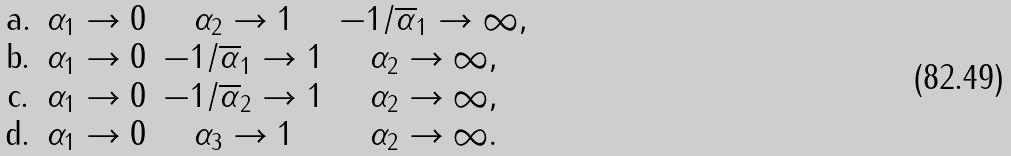Convert formula to latex. <formula><loc_0><loc_0><loc_500><loc_500>\begin{matrix} \text {a.} & \alpha _ { 1 } \rightarrow 0 & \alpha _ { 2 } \rightarrow 1 & { - 1 } / { \overline { \alpha } _ { 1 } } \rightarrow \infty , \\ \text {b.} & \alpha _ { 1 } \rightarrow 0 & { - 1 } / { \overline { \alpha } _ { 1 } } \rightarrow 1 & \alpha _ { 2 } \rightarrow \infty , \\ \text {c.} & \alpha _ { 1 } \rightarrow 0 & { - 1 } / { \overline { \alpha } _ { 2 } } \rightarrow 1 & \alpha _ { 2 } \rightarrow \infty , \\ \text {d.} & \alpha _ { 1 } \rightarrow 0 & \alpha _ { 3 } \rightarrow 1 & \alpha _ { 2 } \rightarrow \infty . \end{matrix}</formula> 